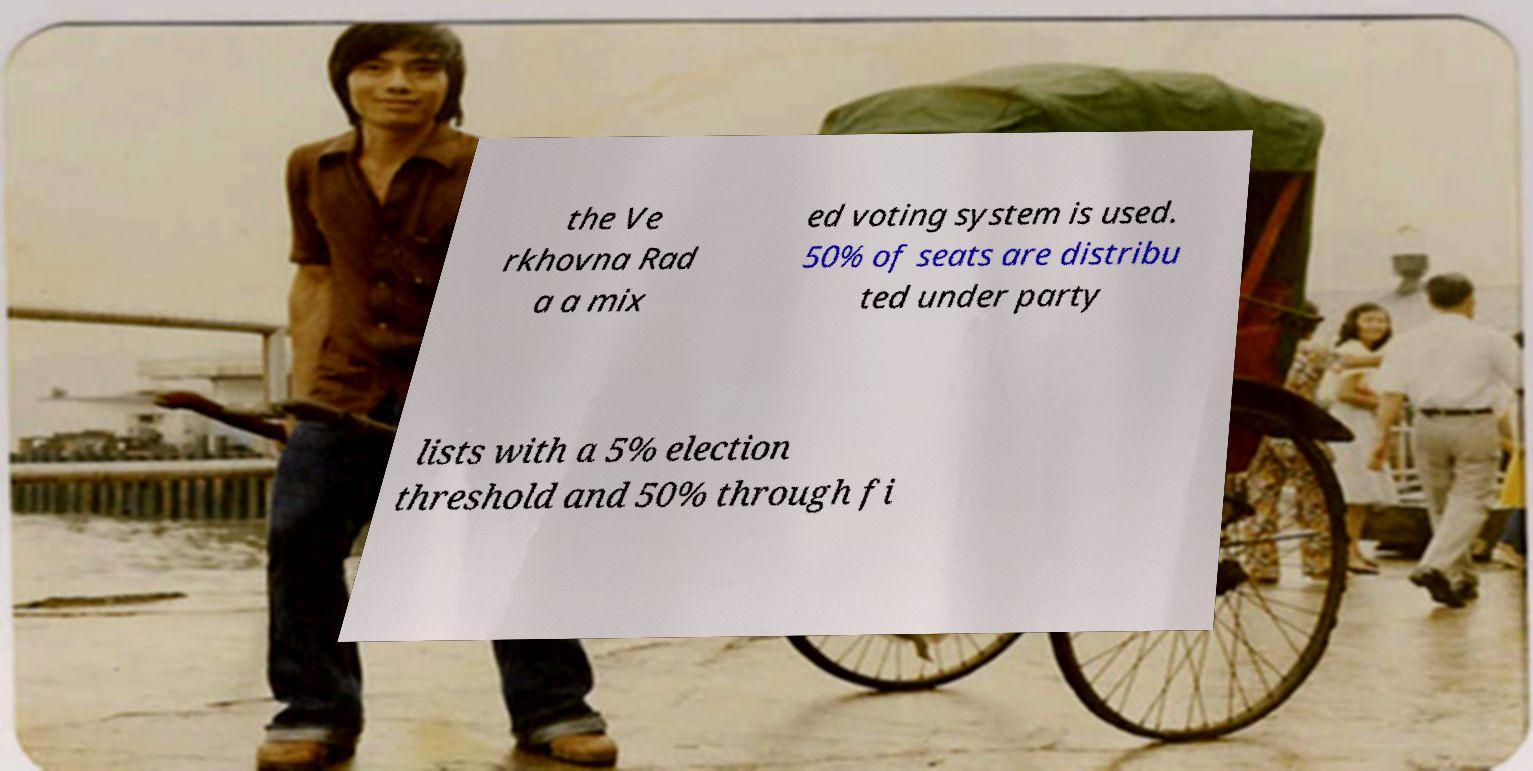Could you assist in decoding the text presented in this image and type it out clearly? the Ve rkhovna Rad a a mix ed voting system is used. 50% of seats are distribu ted under party lists with a 5% election threshold and 50% through fi 